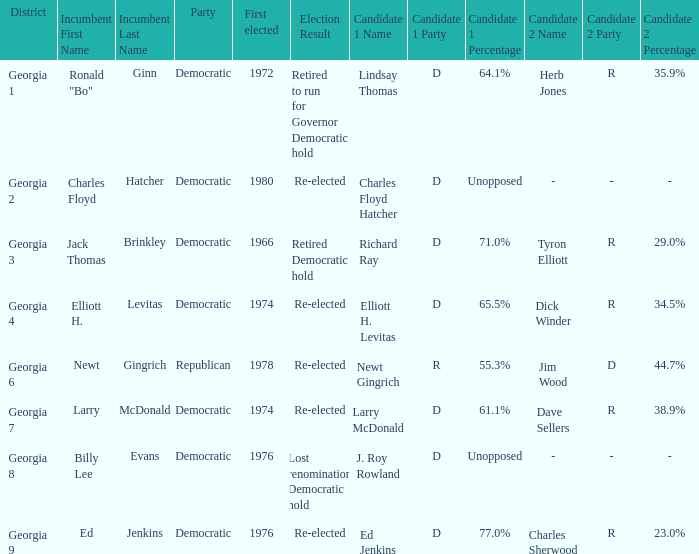Name the party of georgia 4 Democratic. 